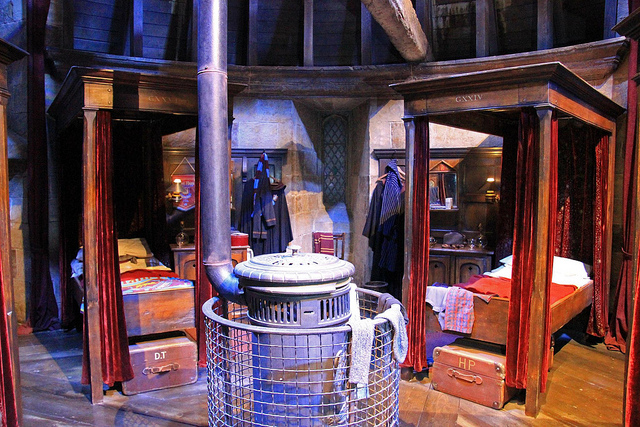<image>What movie is this from? I don't know what movie this is from. It could possibly be from 'Harry Potter', 'Clone' or 'Annie'. What movie is this from? I don't know which movie this is from. It could be from 'clone', 'harry potter', 'lost', or 'annie'. 